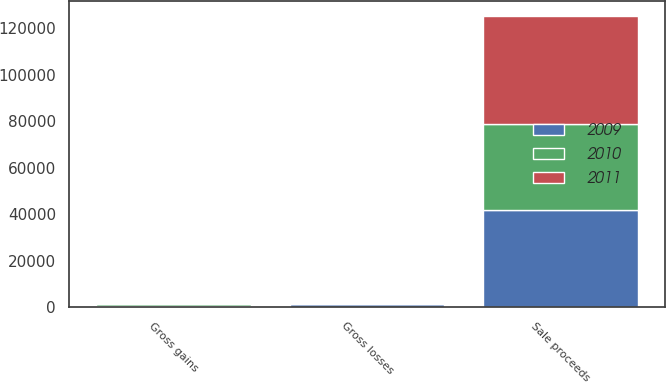Convert chart to OTSL. <chart><loc_0><loc_0><loc_500><loc_500><stacked_bar_chart><ecel><fcel>Sale proceeds<fcel>Gross gains<fcel>Gross losses<nl><fcel>2010<fcel>36956<fcel>617<fcel>381<nl><fcel>2011<fcel>46482<fcel>706<fcel>452<nl><fcel>2009<fcel>41973<fcel>755<fcel>1272<nl></chart> 